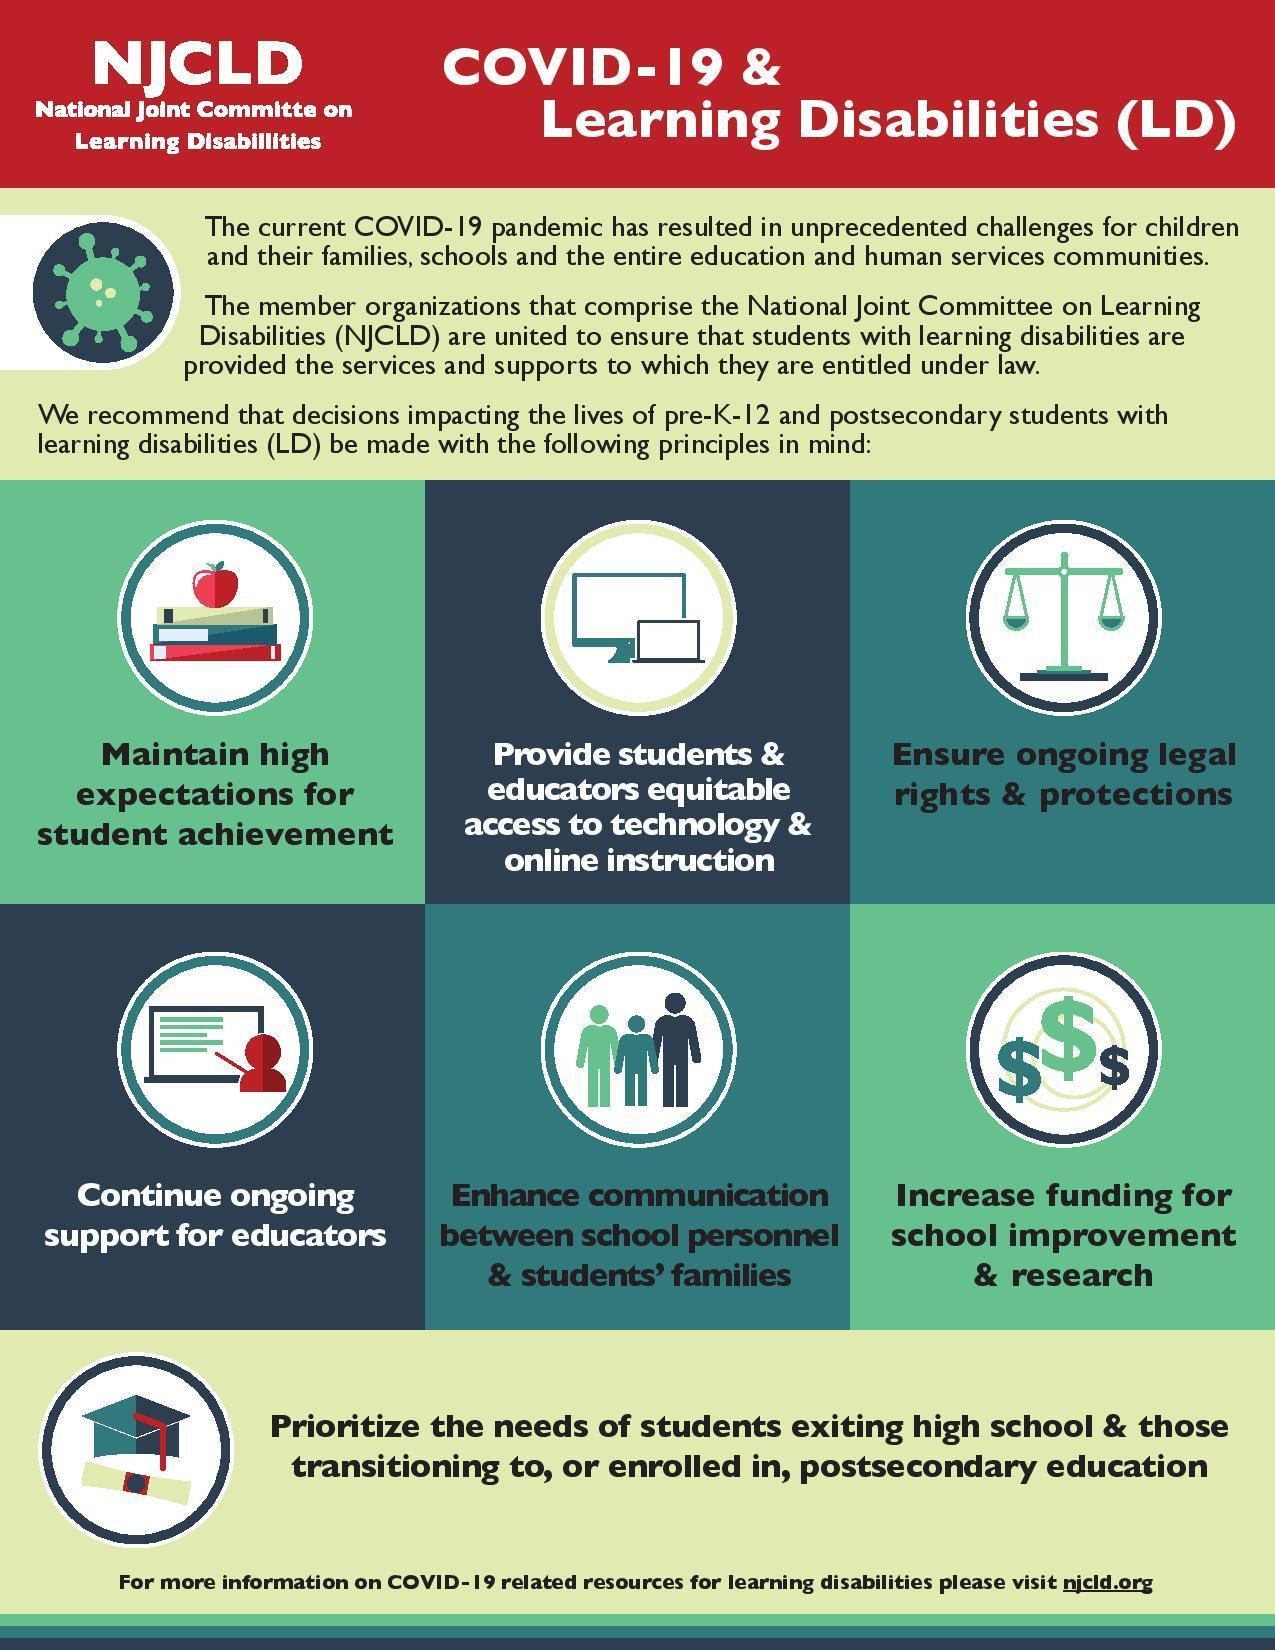How many principles are in this infographic?
Answer the question with a short phrase. 6 Which is the fifth principle in this infographic? Enhance communication between school personnel & students' families Which is the third principle in this infographic? Ensure ongoing legal rights & protections Which is the fourth principle in this infographic? Continue ongoing support for educators Which is the sixth principle in this infographic? Increase funding for school improvement & research 